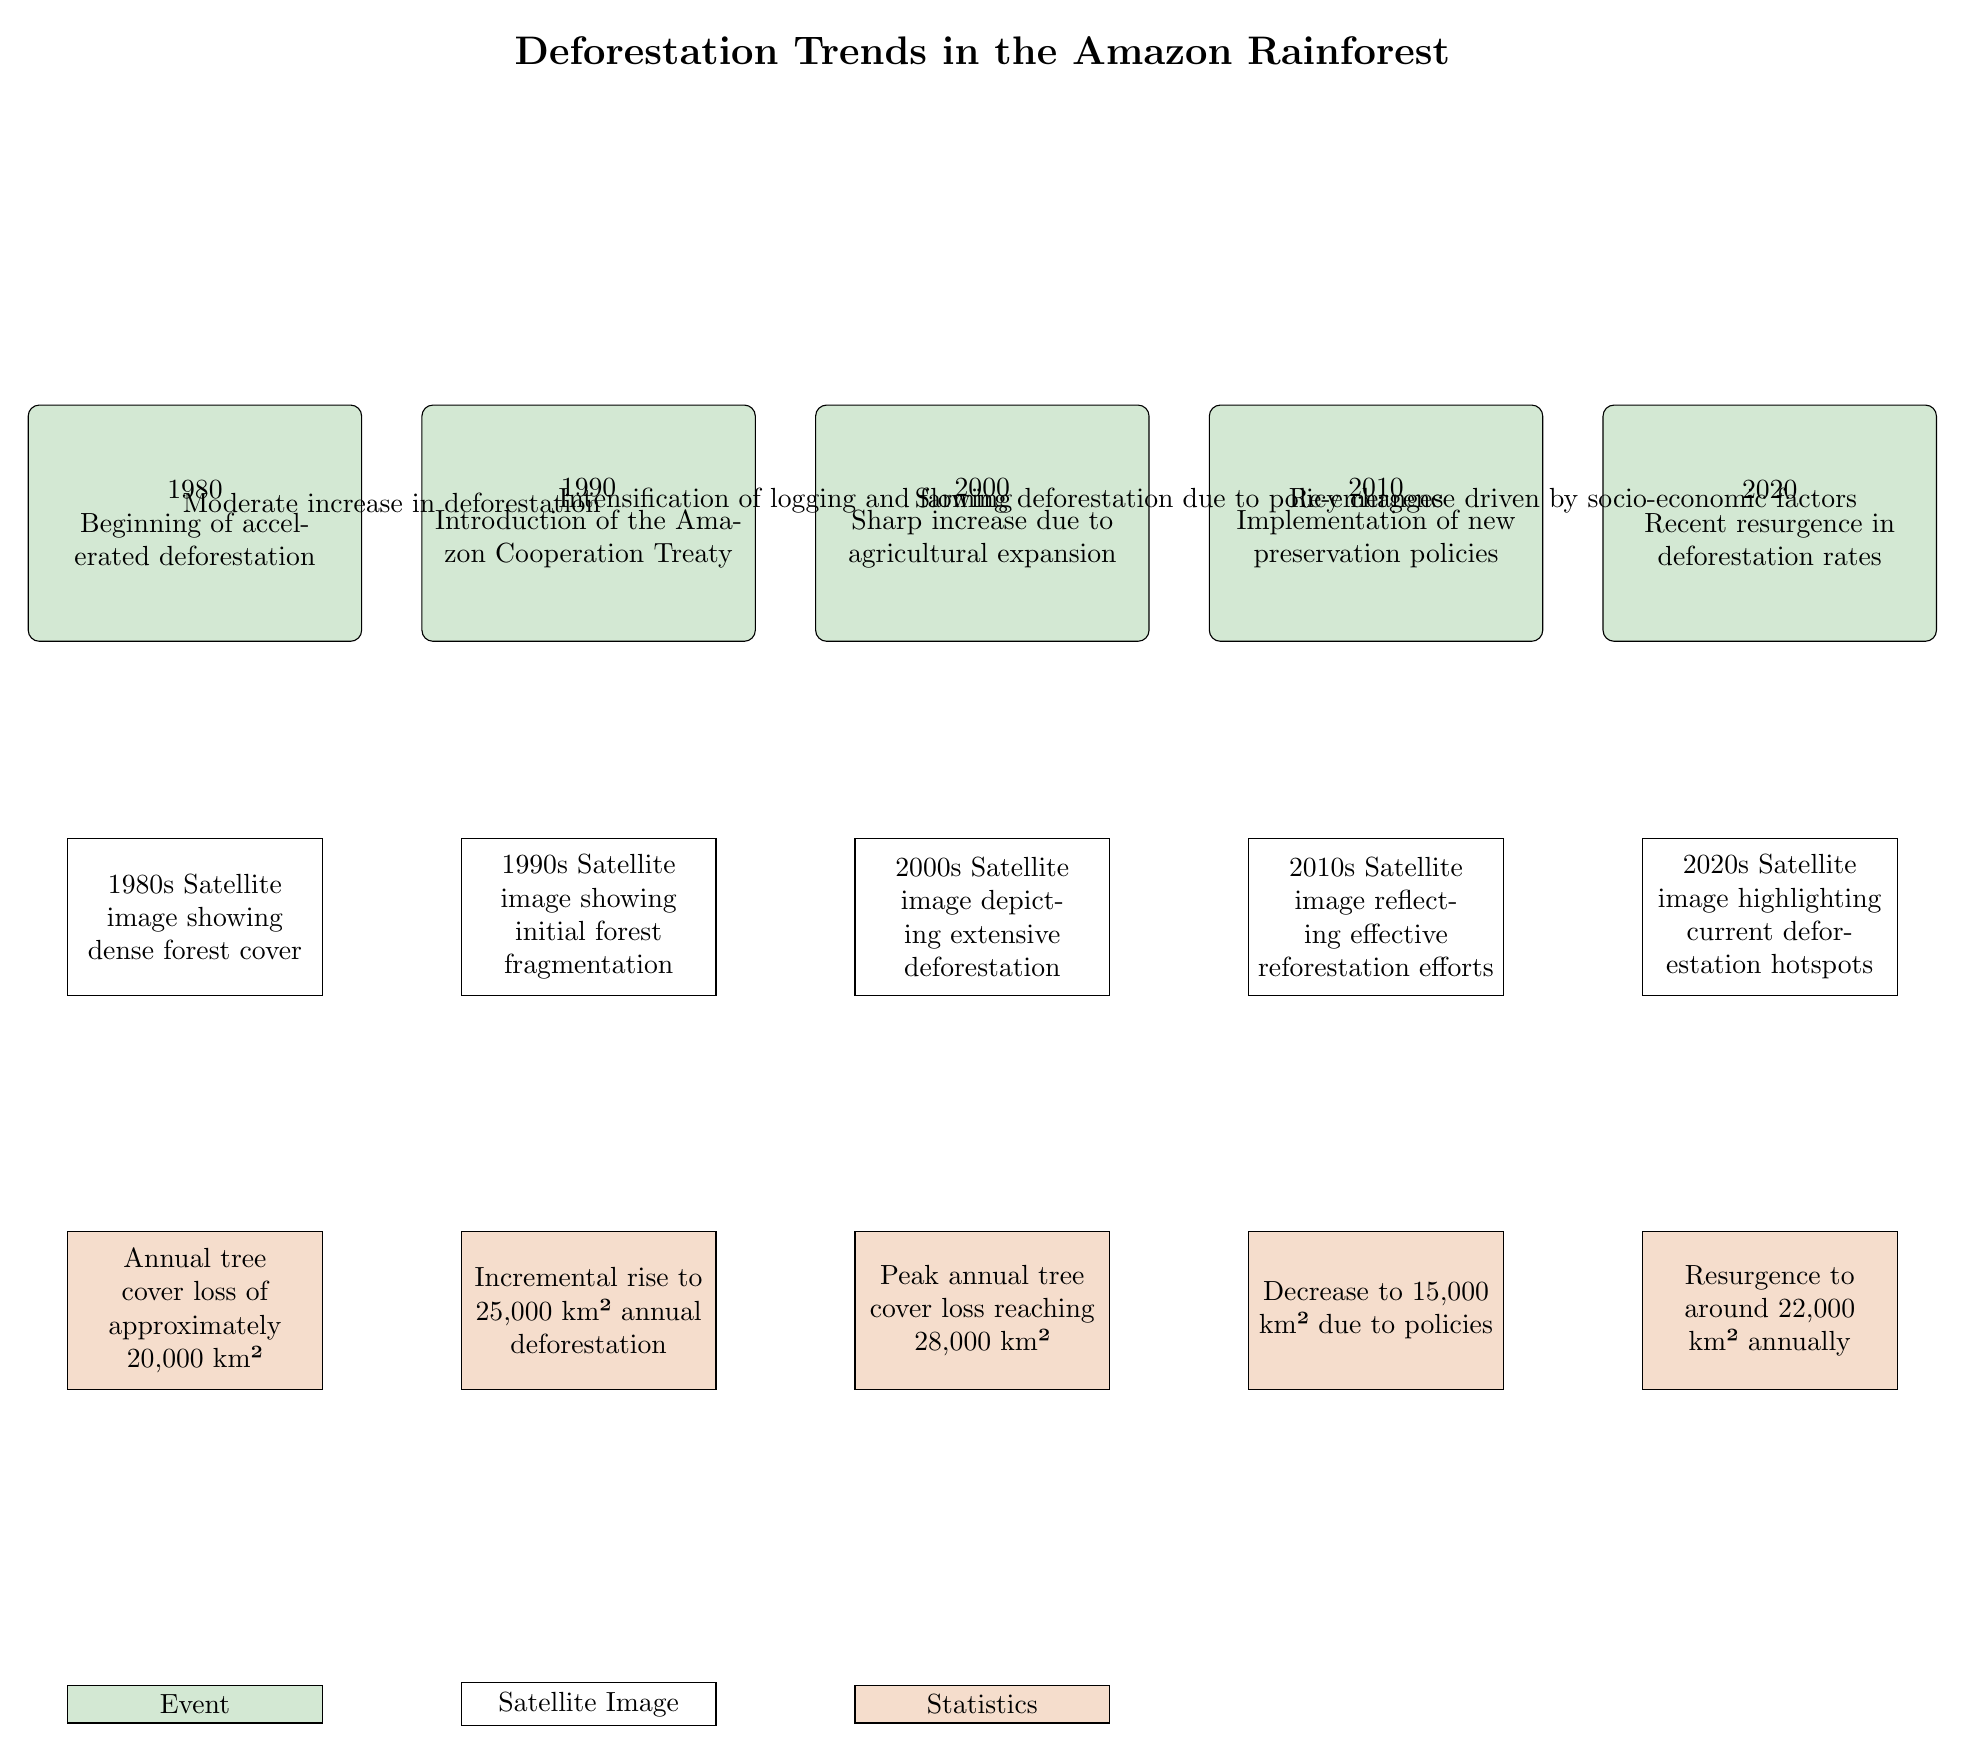What year did deforestation begin to accelerate? The diagram indicates that deforestation began to accelerate in 1980, as stated in the first event node.
Answer: 1980 What is the annual tree cover loss in 2000? Referring to the statistics node corresponding to the year 2000, it states that the peak annual tree cover loss reached 28,000 km².
Answer: 28,000 km² Which event led to a decrease in annual deforestation rates? The event that indicates a decrease in annual deforestation is the implementation of new preservation policies in 2010, shown in the corresponding node.
Answer: Implementation of new preservation policies What was the change in annual tree cover loss from 2010 to 2020? In 2010, the annual tree cover loss was reduced to 15,000 km², but by 2020 it rose to around 22,000 km². The change is calculated as 22,000 km² - 15,000 km², resulting in an increase of 7,000 km².
Answer: Increase of 7,000 km² What event caused a sharp increase in deforestation rates? The event causing a sharp increase in deforestation rates is the agricultural expansion in 2000, indicated by the connection from the 1990 node to the 2000 node.
Answer: Agricultural expansion What was the annual deforestation rate in the 1990s? According to the diagram, the annual deforestation rate increased to 25,000 km² in 1990, reflecting the higher rate during the 1990s.
Answer: 25,000 km² How many nodes represent satellite images in the diagram? The diagram features five nodes representing satellite images, one for each year from 1980 to 2020.
Answer: Five nodes What socio-economic factors contributed to the resurgence in deforestation rates by 2020? The diagram mentions "socio-economic factors" in the arrow connecting the 2010 to the 2020 event nodes, implying that these broader factors drove the increase in rates.
Answer: Socio-economic factors 